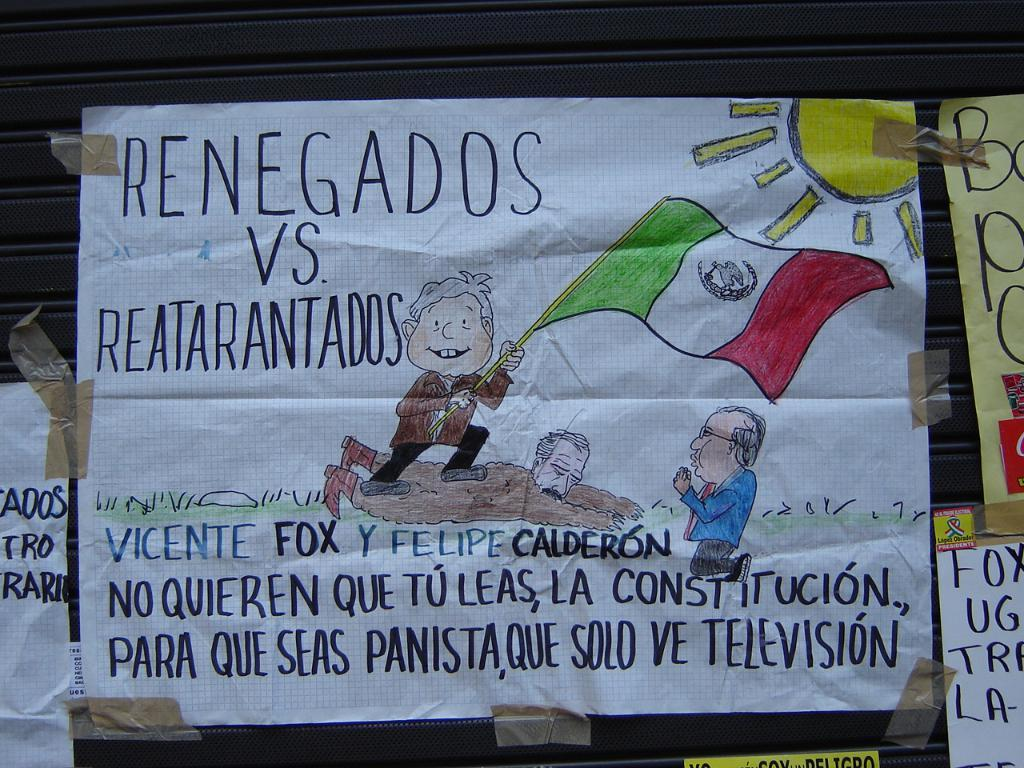What type of material is featured in the image? There are painted papers in the image. How are the painted papers arranged or displayed? The painted papers are attached to an object that resembles a shatter. What type of brain activity can be observed in the image? There is no brain activity present in the image; it features painted papers attached to an object that resembles a shatter. 